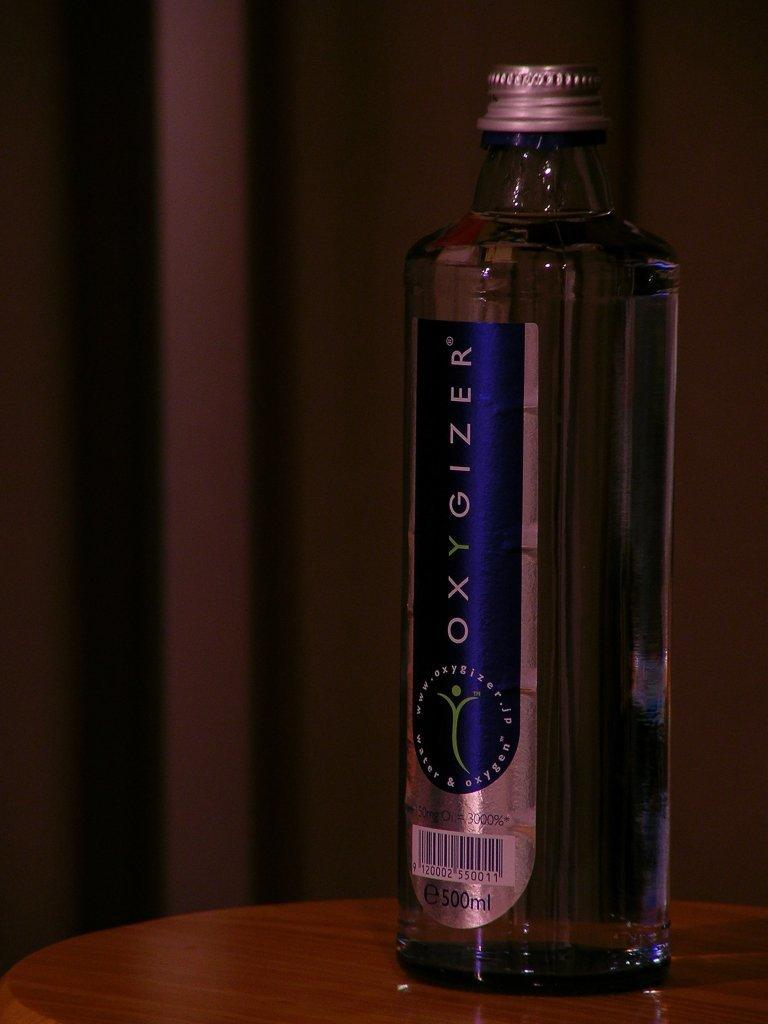<image>
Relay a brief, clear account of the picture shown. a bottle that says the word 'oxygizer' on the label 